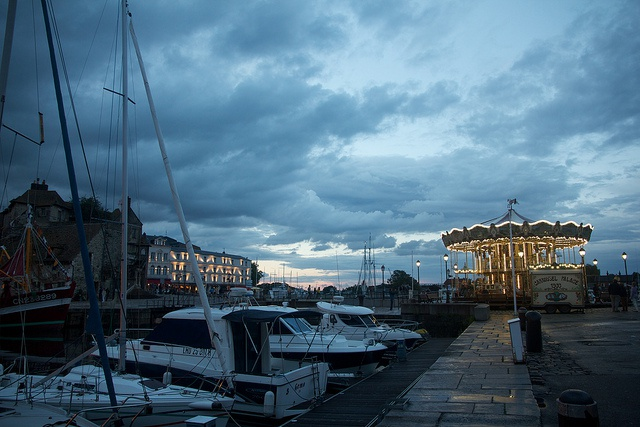Describe the objects in this image and their specific colors. I can see boat in blue, black, darkblue, and gray tones, boat in blue, black, darkblue, and maroon tones, boat in blue, black, navy, and gray tones, boat in blue, black, and gray tones, and boat in blue, black, and gray tones in this image. 